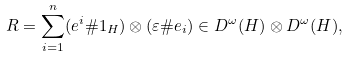<formula> <loc_0><loc_0><loc_500><loc_500>R = \sum _ { i = 1 } ^ { n } ( e ^ { i } \# 1 _ { H } ) \otimes ( \varepsilon \# e _ { i } ) \in D ^ { \omega } ( H ) \otimes D ^ { \omega } ( H ) ,</formula> 